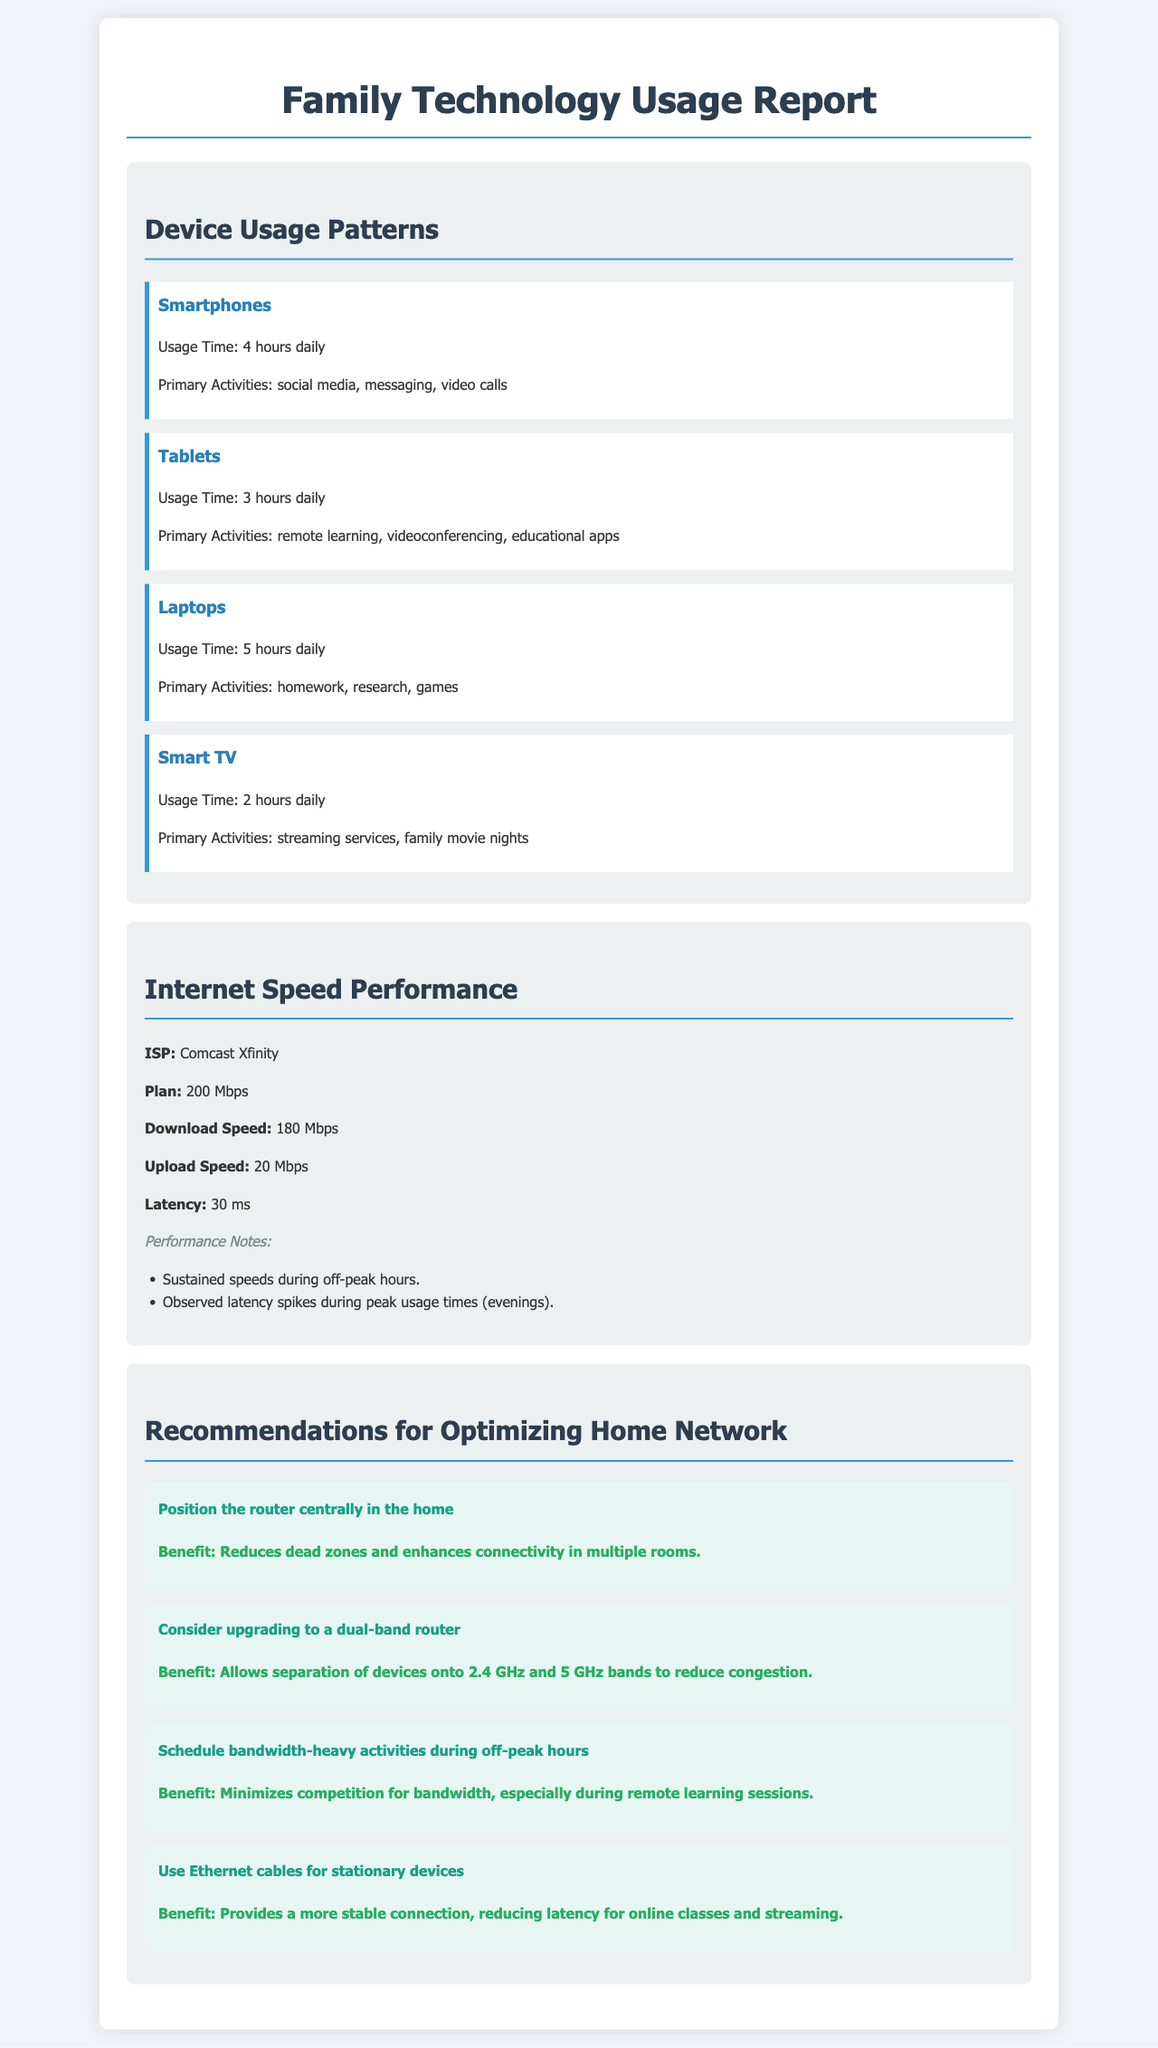What is the daily usage time for smartphones? The daily usage time for smartphones is specified in the device usage section of the report, which states 4 hours daily.
Answer: 4 hours daily What activities are primarily done on tablets? The document lists the primary activities for tablets in the device usage section as remote learning, videoconferencing, and educational apps.
Answer: remote learning, videoconferencing, educational apps What is the download speed as stated in the report? The download speed is one of the key metrics provided under the internet speed performance section, which is 180 Mbps.
Answer: 180 Mbps What recommendation is made for positioning the router? The recommendations section includes a specific suggestion about the router's position, stating to position it centrally in the home.
Answer: centrally in the home How much is the upload speed reported? The upload speed is another important metric highlighted in the internet speed performance section, which is listed as 20 Mbps.
Answer: 20 Mbps What issue is noted regarding latency? The performance notes in the internet speed performance section describe latency spikes occurring during peak usage times, specifically in the evenings.
Answer: during peak usage times (evenings) What is one benefit of using Ethernet cables for stationary devices? The document highlights the benefit of using Ethernet cables in the recommendations section, emphasizing that it provides a more stable connection for online classes and streaming.
Answer: more stable connection What is the ISP identified in the report? The ISP is mentioned in the internet speed performance section as Comcast Xfinity.
Answer: Comcast Xfinity 